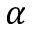Convert formula to latex. <formula><loc_0><loc_0><loc_500><loc_500>\alpha</formula> 